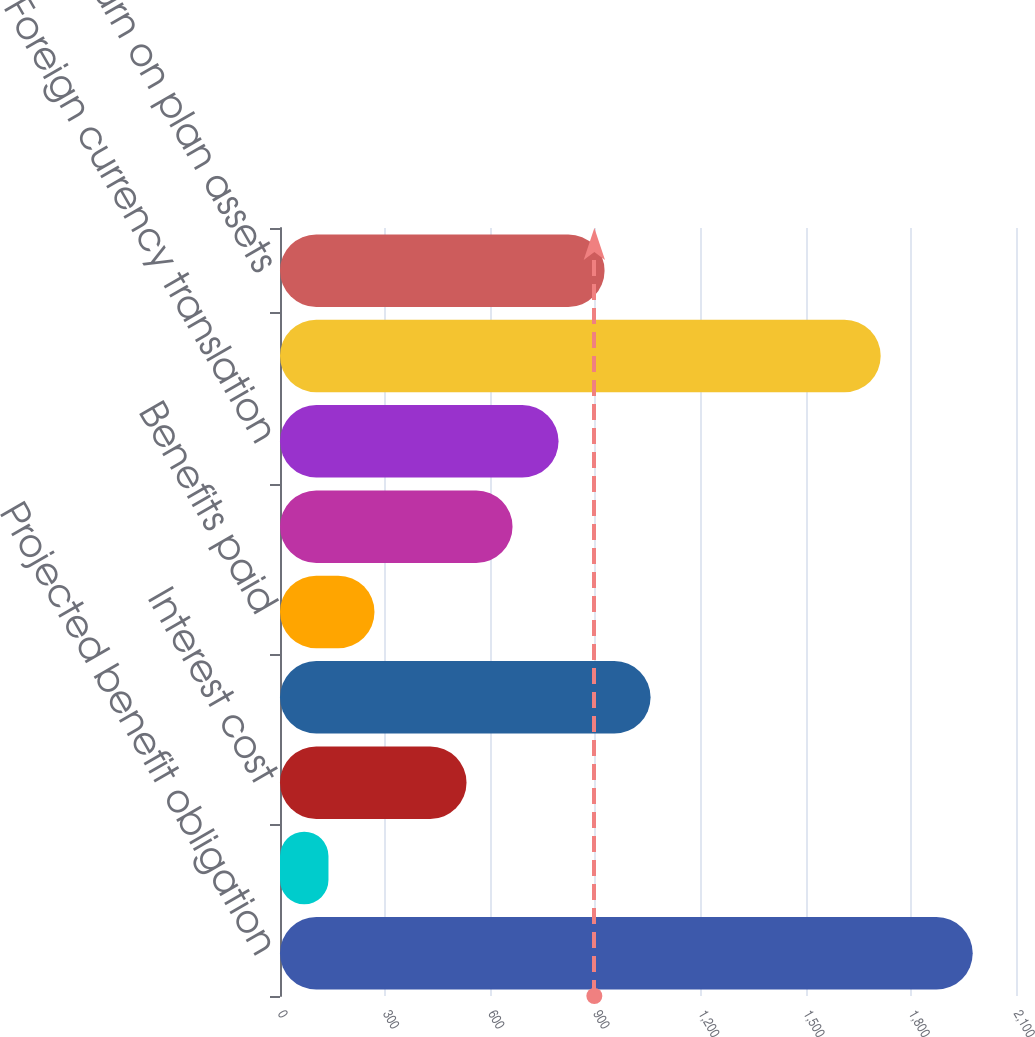Convert chart to OTSL. <chart><loc_0><loc_0><loc_500><loc_500><bar_chart><fcel>Projected benefit obligation<fcel>Service cost<fcel>Interest cost<fcel>Actuarial (gain) loss<fcel>Benefits paid<fcel>Settlements<fcel>Foreign currency translation<fcel>Fair value of plan assets<fcel>Actual return on plan assets<nl><fcel>1976.5<fcel>138.3<fcel>532.2<fcel>1057.4<fcel>269.6<fcel>663.5<fcel>794.8<fcel>1713.9<fcel>926.1<nl></chart> 